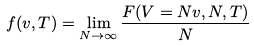Convert formula to latex. <formula><loc_0><loc_0><loc_500><loc_500>f ( v , T ) = \lim _ { N \to \infty } \frac { F ( V = N v , N , T ) } { N }</formula> 